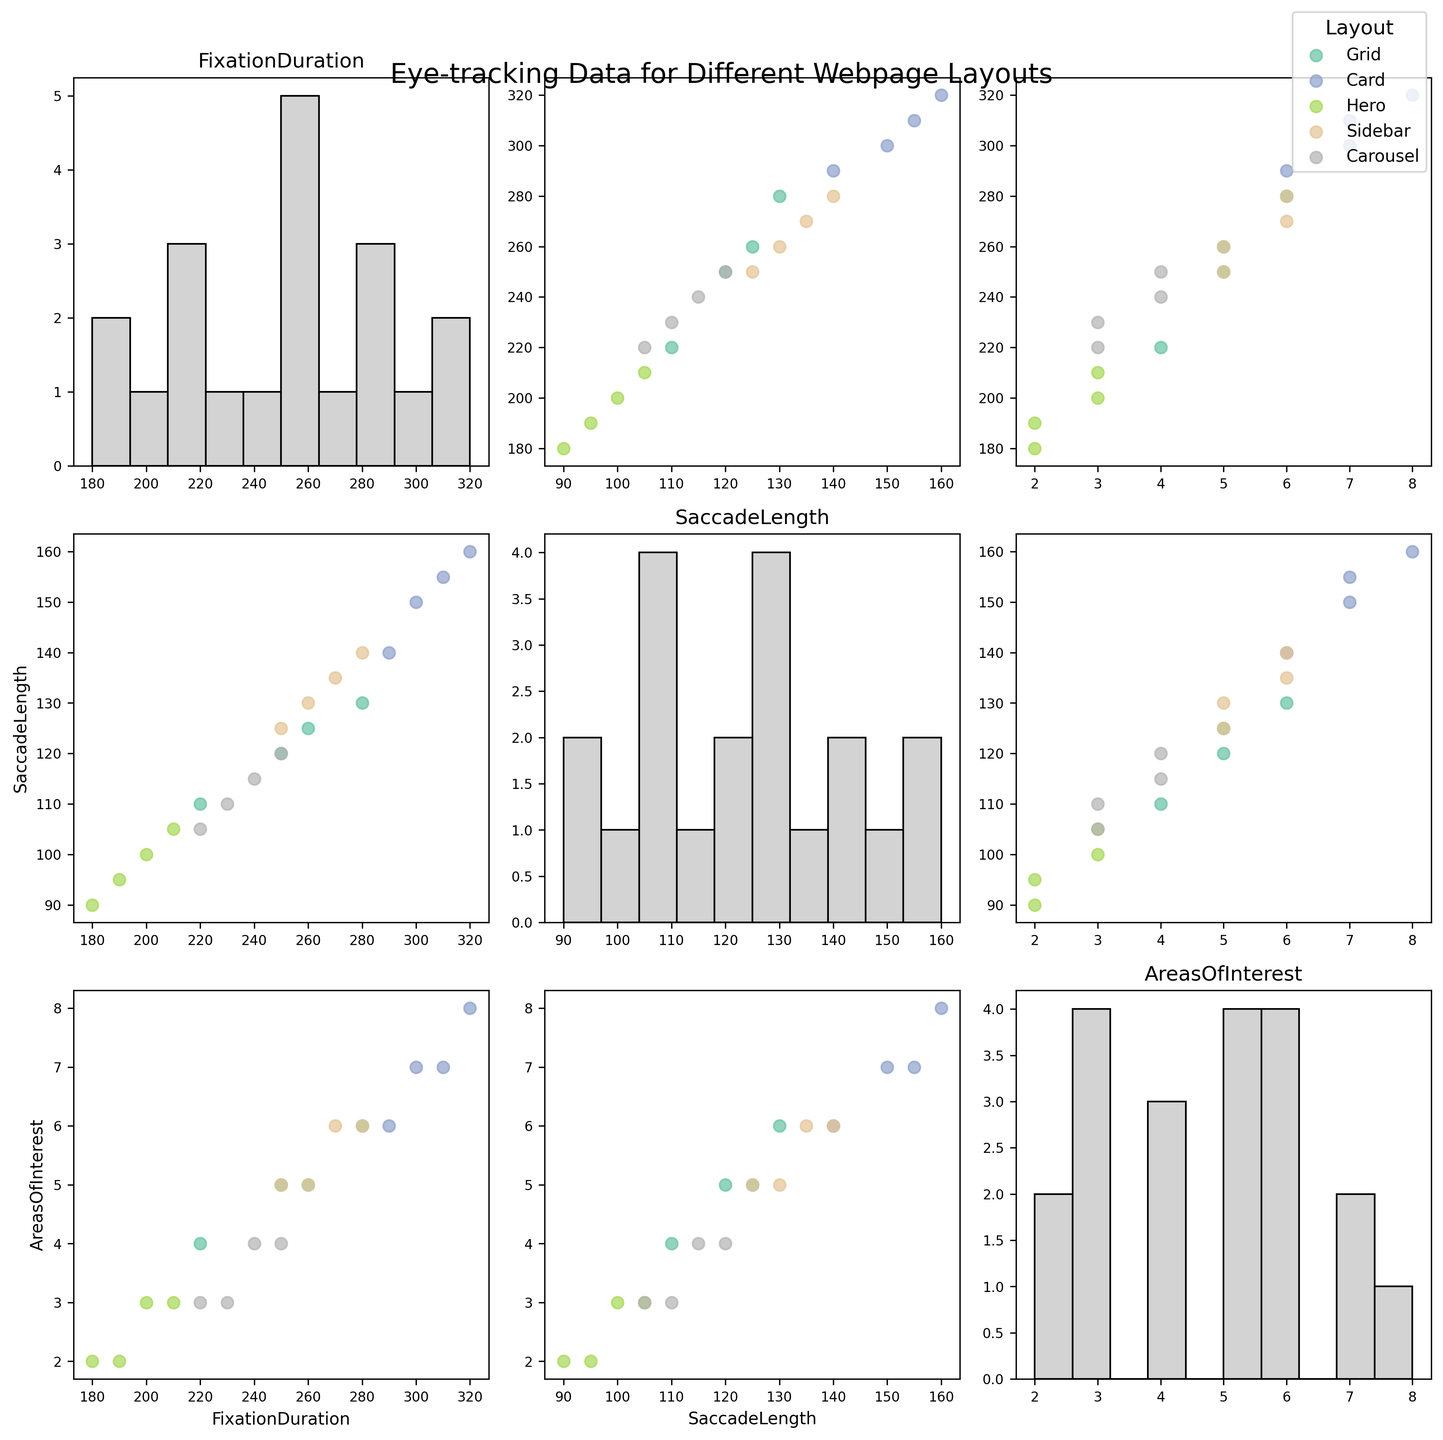what is the title of the chart? The title of the figure can be read directly from the text at the top of the figure that provides an overall description.
Answer: Eye-tracking Data for Different Webpage Layouts What are the three features shown on the axes of the scatter plot matrix? The features of the scatter plot matrix are labeled along the axes. By checking the axes, you can determine the features being plotted.
Answer: Fixation Duration, Saccade Length, Areas of Interest How many different layout types are represented in this scatter plot matrix? By looking at the colors and the legend on the figure, all the unique layout types represented can be identified.
Answer: 5 Are there any layouts that have saccade lengths greater than 150 units? By examining the scatter plots where Saccade Length is an axis, you can see if any points exceed 150 units.
Answer: Yes Which layout has the highest fixation duration on average? By comparing the centroid of the scatter points related to Fixation Duration for each layout, it can be deduced where the average values lie.
Answer: Card Do any layouts have points concentrated near Fixation Duration = 200 and Saccade Length = 100? By visually inspecting scatter plots involving Fixation Duration and Saccade Length axes, it can be checked if there are clustered points around these values.
Answer: Yes On average, do layouts with higher Fixation Durations have fewer or greater Areas of Interest? By examining the overall trend of the scatter plots involving Fixation Duration and Areas of Interest, an inclination can be identified.
Answer: Greater Are the fixation durations for the Hero layout generally lower than those of the Card layout? By comparing the scatter plots involving Fixation Duration for Hero and Card layouts, a general trend can be identified.
Answer: Yes Is there any noticeable trend between Saccade Length and Areas of Interest across different layouts? By comparing scatter plots involving Saccade Length and Areas of Interest across different layouts, any general trend or pattern can be observed.
Answer: No noticeable trend What is the range of Areas of Interest for the Carousel layout? By examining the scatter points in plots featuring Areas of Interest for the Carousel layout, the minimum and maximum values can be identified.
Answer: 3-4 